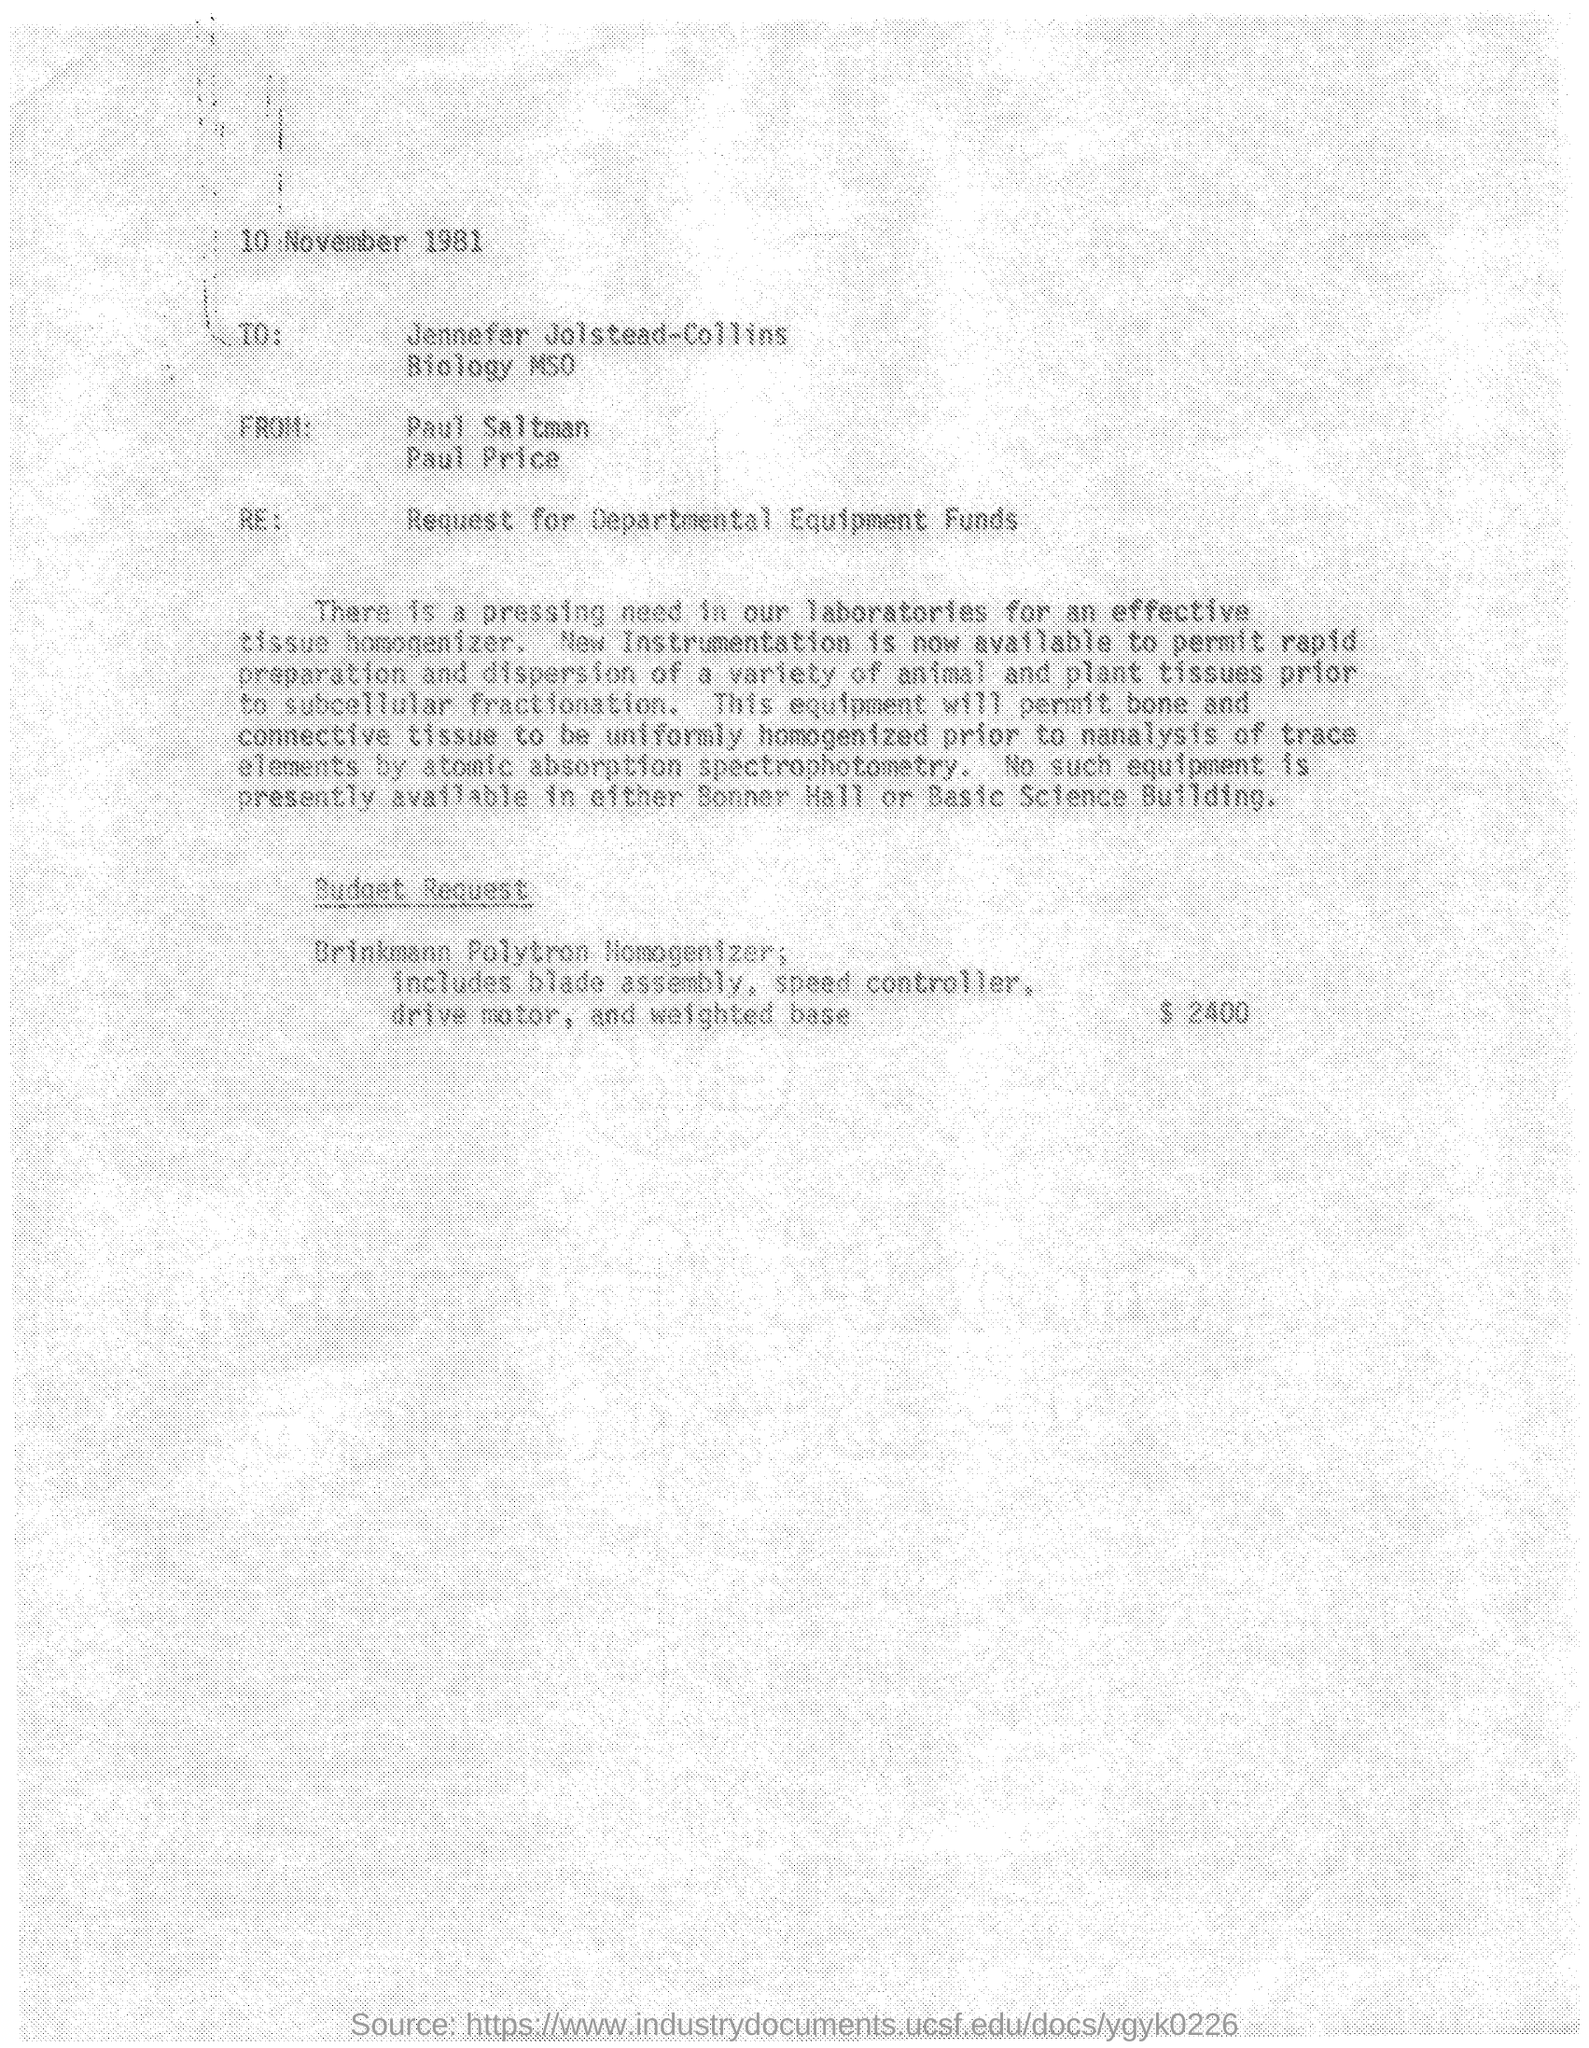When was letter dated ?
Your answer should be compact. 10 NOVEMBER 1981. 